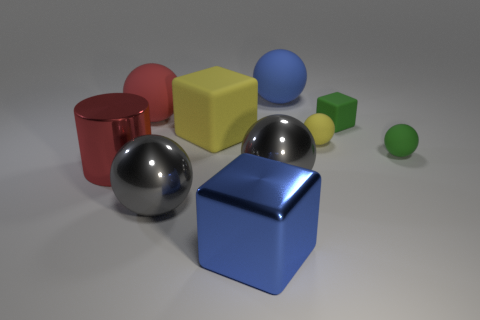Is the number of big balls that are left of the metallic cylinder the same as the number of small things in front of the tiny yellow ball?
Give a very brief answer. No. Are there any big balls made of the same material as the tiny yellow sphere?
Offer a terse response. Yes. Do the yellow object that is to the left of the large blue sphere and the red sphere have the same material?
Your response must be concise. Yes. There is a rubber ball that is to the right of the blue matte sphere and on the left side of the tiny green matte sphere; what size is it?
Offer a terse response. Small. The large shiny cylinder has what color?
Offer a very short reply. Red. What number of tiny brown things are there?
Provide a short and direct response. 0. How many metal blocks have the same color as the shiny cylinder?
Give a very brief answer. 0. Is the shape of the large red object on the left side of the large red rubber sphere the same as the yellow rubber object right of the blue sphere?
Your answer should be compact. No. What is the color of the rubber sphere right of the block to the right of the thing that is behind the red rubber sphere?
Provide a short and direct response. Green. There is a large block behind the red cylinder; what color is it?
Offer a very short reply. Yellow. 